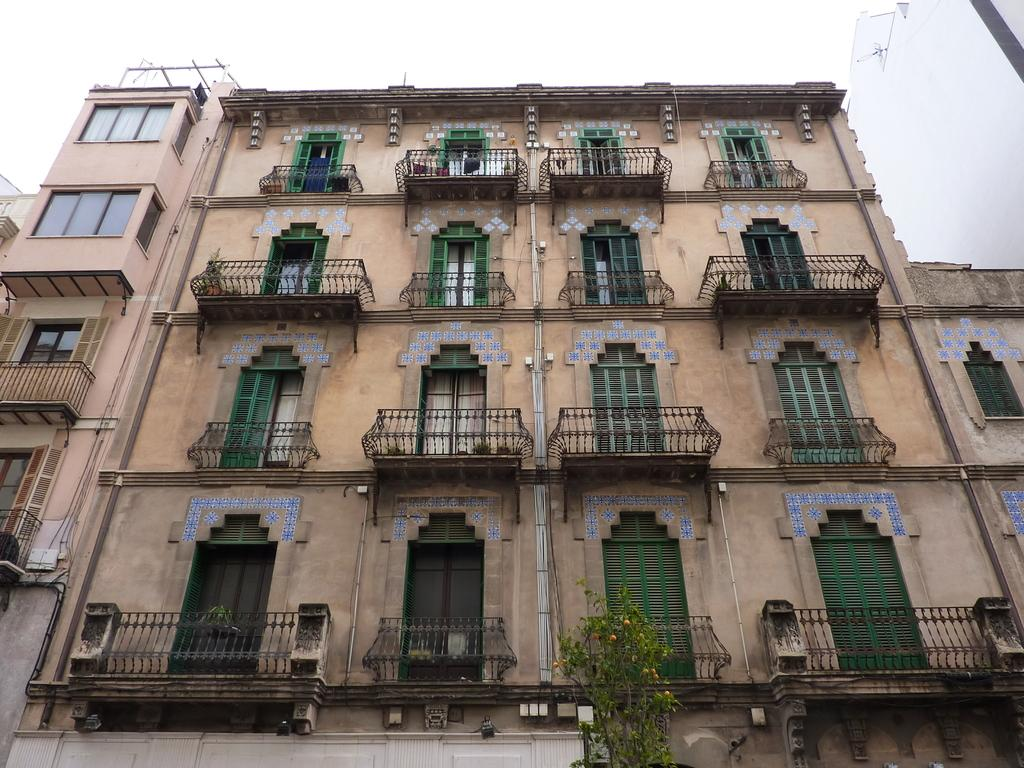What type of structures are present in the image? There are buildings in the image. What features can be seen on the buildings? The buildings have doors, windows, and balcony railings. What other object is visible in the image? There is a tree in the image. What is visible at the top of the image? The sky is visible at the top of the image. What type of coat is the tree wearing in the image? Trees do not wear coats, so this question is not applicable to the image. 